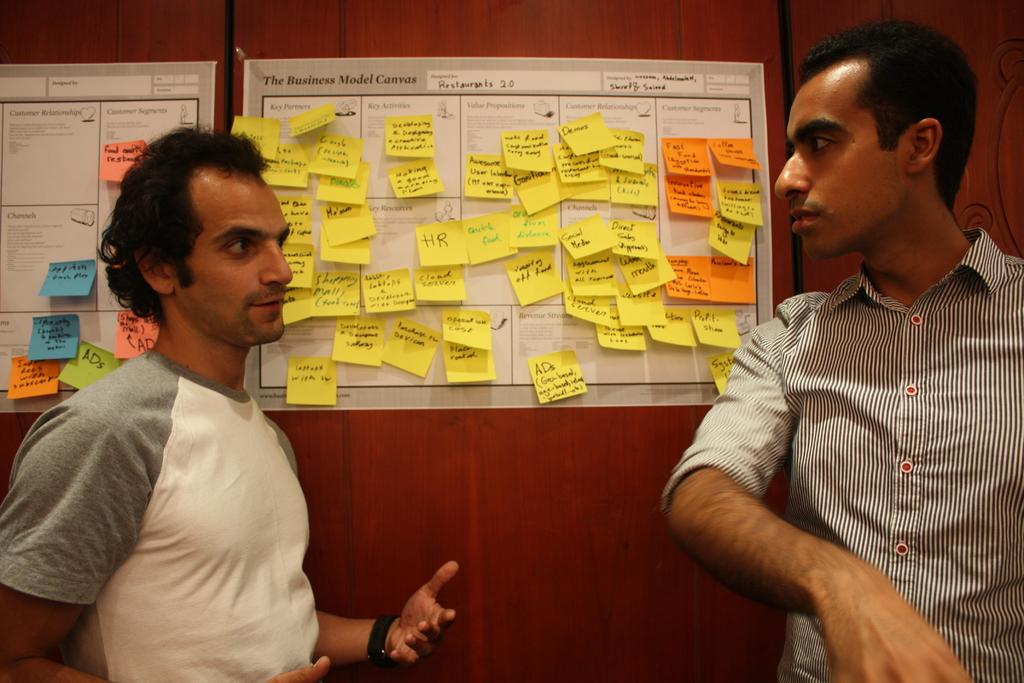Who is present in the image? There are men standing in the image. What type of doors can be seen in the image? There are wooden doors in the image. What is on the wooden doors? There are posters on the wooden doors. What is on the posters? There are stick papers on the posters. What type of lift can be seen in the image? There is no lift present in the image. What kind of structure is the hen standing on in the image? There is no hen present in the image. 